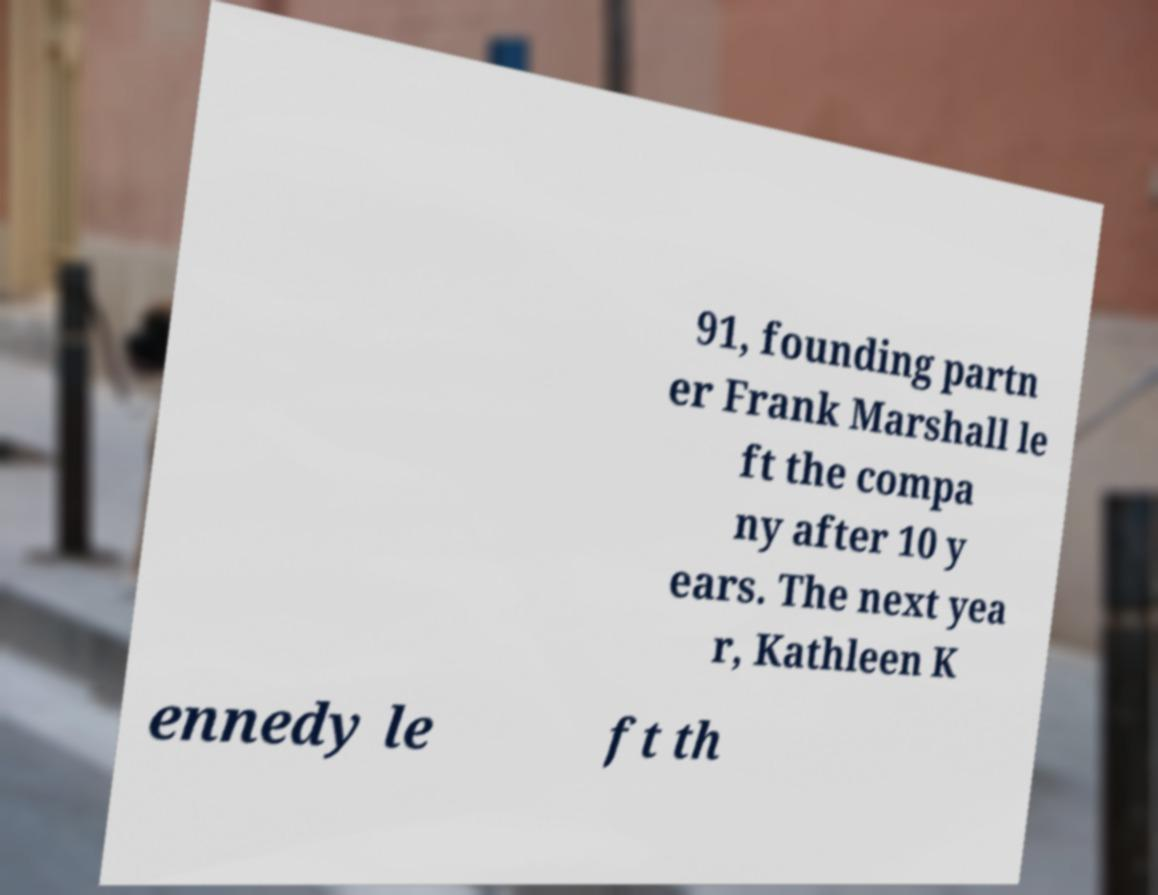Can you read and provide the text displayed in the image?This photo seems to have some interesting text. Can you extract and type it out for me? 91, founding partn er Frank Marshall le ft the compa ny after 10 y ears. The next yea r, Kathleen K ennedy le ft th 